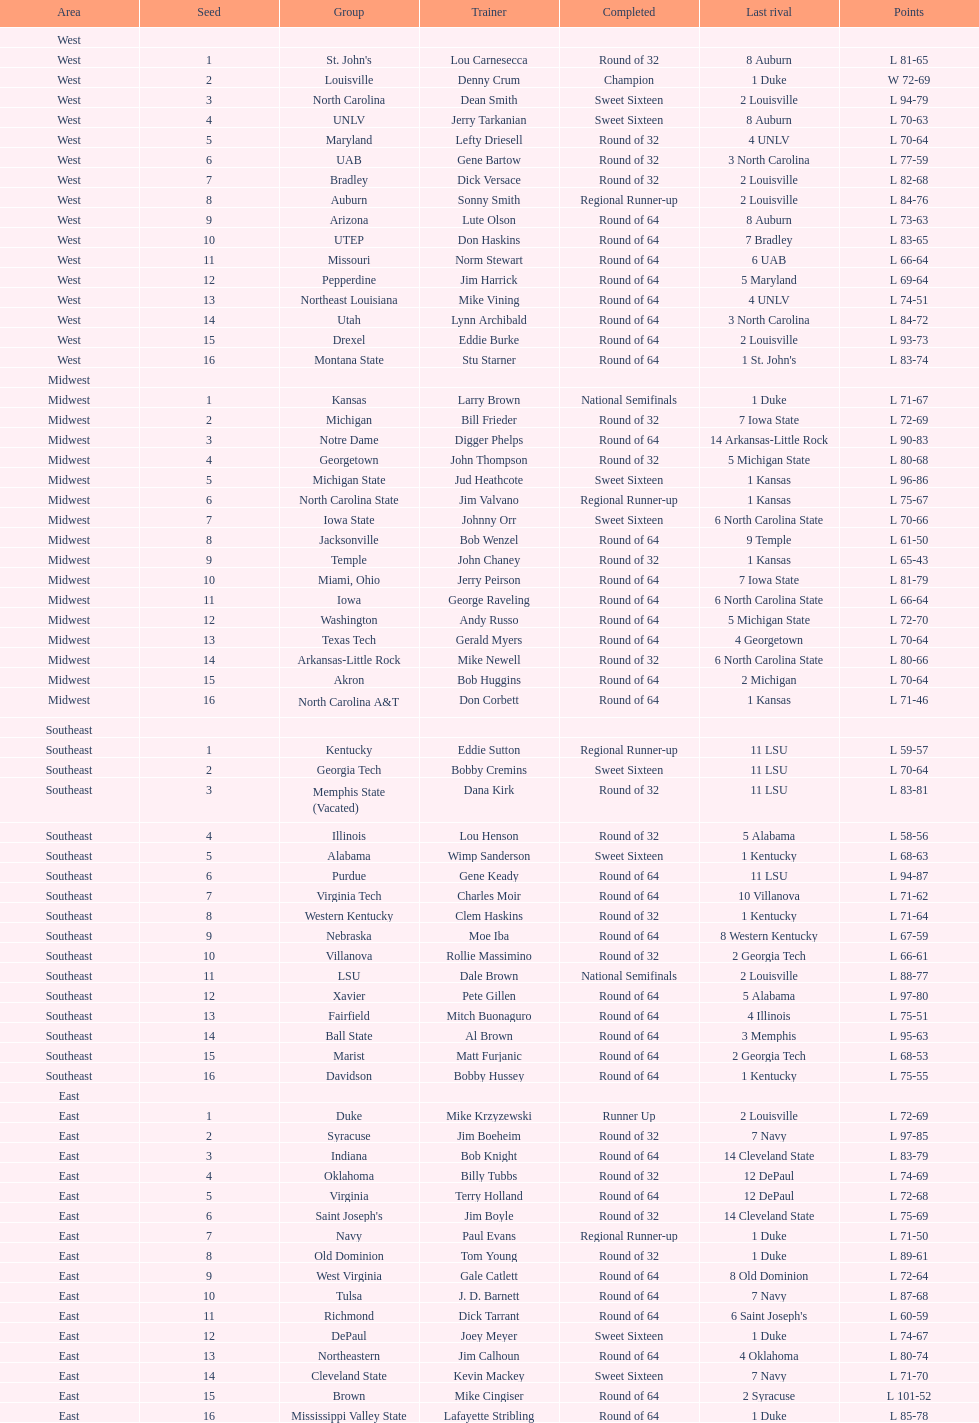Which area is mentioned prior to the midwest? West. Would you be able to parse every entry in this table? {'header': ['Area', 'Seed', 'Group', 'Trainer', 'Completed', 'Last rival', 'Points'], 'rows': [['West', '', '', '', '', '', ''], ['West', '1', "St. John's", 'Lou Carnesecca', 'Round of 32', '8 Auburn', 'L 81-65'], ['West', '2', 'Louisville', 'Denny Crum', 'Champion', '1 Duke', 'W 72-69'], ['West', '3', 'North Carolina', 'Dean Smith', 'Sweet Sixteen', '2 Louisville', 'L 94-79'], ['West', '4', 'UNLV', 'Jerry Tarkanian', 'Sweet Sixteen', '8 Auburn', 'L 70-63'], ['West', '5', 'Maryland', 'Lefty Driesell', 'Round of 32', '4 UNLV', 'L 70-64'], ['West', '6', 'UAB', 'Gene Bartow', 'Round of 32', '3 North Carolina', 'L 77-59'], ['West', '7', 'Bradley', 'Dick Versace', 'Round of 32', '2 Louisville', 'L 82-68'], ['West', '8', 'Auburn', 'Sonny Smith', 'Regional Runner-up', '2 Louisville', 'L 84-76'], ['West', '9', 'Arizona', 'Lute Olson', 'Round of 64', '8 Auburn', 'L 73-63'], ['West', '10', 'UTEP', 'Don Haskins', 'Round of 64', '7 Bradley', 'L 83-65'], ['West', '11', 'Missouri', 'Norm Stewart', 'Round of 64', '6 UAB', 'L 66-64'], ['West', '12', 'Pepperdine', 'Jim Harrick', 'Round of 64', '5 Maryland', 'L 69-64'], ['West', '13', 'Northeast Louisiana', 'Mike Vining', 'Round of 64', '4 UNLV', 'L 74-51'], ['West', '14', 'Utah', 'Lynn Archibald', 'Round of 64', '3 North Carolina', 'L 84-72'], ['West', '15', 'Drexel', 'Eddie Burke', 'Round of 64', '2 Louisville', 'L 93-73'], ['West', '16', 'Montana State', 'Stu Starner', 'Round of 64', "1 St. John's", 'L 83-74'], ['Midwest', '', '', '', '', '', ''], ['Midwest', '1', 'Kansas', 'Larry Brown', 'National Semifinals', '1 Duke', 'L 71-67'], ['Midwest', '2', 'Michigan', 'Bill Frieder', 'Round of 32', '7 Iowa State', 'L 72-69'], ['Midwest', '3', 'Notre Dame', 'Digger Phelps', 'Round of 64', '14 Arkansas-Little Rock', 'L 90-83'], ['Midwest', '4', 'Georgetown', 'John Thompson', 'Round of 32', '5 Michigan State', 'L 80-68'], ['Midwest', '5', 'Michigan State', 'Jud Heathcote', 'Sweet Sixteen', '1 Kansas', 'L 96-86'], ['Midwest', '6', 'North Carolina State', 'Jim Valvano', 'Regional Runner-up', '1 Kansas', 'L 75-67'], ['Midwest', '7', 'Iowa State', 'Johnny Orr', 'Sweet Sixteen', '6 North Carolina State', 'L 70-66'], ['Midwest', '8', 'Jacksonville', 'Bob Wenzel', 'Round of 64', '9 Temple', 'L 61-50'], ['Midwest', '9', 'Temple', 'John Chaney', 'Round of 32', '1 Kansas', 'L 65-43'], ['Midwest', '10', 'Miami, Ohio', 'Jerry Peirson', 'Round of 64', '7 Iowa State', 'L 81-79'], ['Midwest', '11', 'Iowa', 'George Raveling', 'Round of 64', '6 North Carolina State', 'L 66-64'], ['Midwest', '12', 'Washington', 'Andy Russo', 'Round of 64', '5 Michigan State', 'L 72-70'], ['Midwest', '13', 'Texas Tech', 'Gerald Myers', 'Round of 64', '4 Georgetown', 'L 70-64'], ['Midwest', '14', 'Arkansas-Little Rock', 'Mike Newell', 'Round of 32', '6 North Carolina State', 'L 80-66'], ['Midwest', '15', 'Akron', 'Bob Huggins', 'Round of 64', '2 Michigan', 'L 70-64'], ['Midwest', '16', 'North Carolina A&T', 'Don Corbett', 'Round of 64', '1 Kansas', 'L 71-46'], ['Southeast', '', '', '', '', '', ''], ['Southeast', '1', 'Kentucky', 'Eddie Sutton', 'Regional Runner-up', '11 LSU', 'L 59-57'], ['Southeast', '2', 'Georgia Tech', 'Bobby Cremins', 'Sweet Sixteen', '11 LSU', 'L 70-64'], ['Southeast', '3', 'Memphis State (Vacated)', 'Dana Kirk', 'Round of 32', '11 LSU', 'L 83-81'], ['Southeast', '4', 'Illinois', 'Lou Henson', 'Round of 32', '5 Alabama', 'L 58-56'], ['Southeast', '5', 'Alabama', 'Wimp Sanderson', 'Sweet Sixteen', '1 Kentucky', 'L 68-63'], ['Southeast', '6', 'Purdue', 'Gene Keady', 'Round of 64', '11 LSU', 'L 94-87'], ['Southeast', '7', 'Virginia Tech', 'Charles Moir', 'Round of 64', '10 Villanova', 'L 71-62'], ['Southeast', '8', 'Western Kentucky', 'Clem Haskins', 'Round of 32', '1 Kentucky', 'L 71-64'], ['Southeast', '9', 'Nebraska', 'Moe Iba', 'Round of 64', '8 Western Kentucky', 'L 67-59'], ['Southeast', '10', 'Villanova', 'Rollie Massimino', 'Round of 32', '2 Georgia Tech', 'L 66-61'], ['Southeast', '11', 'LSU', 'Dale Brown', 'National Semifinals', '2 Louisville', 'L 88-77'], ['Southeast', '12', 'Xavier', 'Pete Gillen', 'Round of 64', '5 Alabama', 'L 97-80'], ['Southeast', '13', 'Fairfield', 'Mitch Buonaguro', 'Round of 64', '4 Illinois', 'L 75-51'], ['Southeast', '14', 'Ball State', 'Al Brown', 'Round of 64', '3 Memphis', 'L 95-63'], ['Southeast', '15', 'Marist', 'Matt Furjanic', 'Round of 64', '2 Georgia Tech', 'L 68-53'], ['Southeast', '16', 'Davidson', 'Bobby Hussey', 'Round of 64', '1 Kentucky', 'L 75-55'], ['East', '', '', '', '', '', ''], ['East', '1', 'Duke', 'Mike Krzyzewski', 'Runner Up', '2 Louisville', 'L 72-69'], ['East', '2', 'Syracuse', 'Jim Boeheim', 'Round of 32', '7 Navy', 'L 97-85'], ['East', '3', 'Indiana', 'Bob Knight', 'Round of 64', '14 Cleveland State', 'L 83-79'], ['East', '4', 'Oklahoma', 'Billy Tubbs', 'Round of 32', '12 DePaul', 'L 74-69'], ['East', '5', 'Virginia', 'Terry Holland', 'Round of 64', '12 DePaul', 'L 72-68'], ['East', '6', "Saint Joseph's", 'Jim Boyle', 'Round of 32', '14 Cleveland State', 'L 75-69'], ['East', '7', 'Navy', 'Paul Evans', 'Regional Runner-up', '1 Duke', 'L 71-50'], ['East', '8', 'Old Dominion', 'Tom Young', 'Round of 32', '1 Duke', 'L 89-61'], ['East', '9', 'West Virginia', 'Gale Catlett', 'Round of 64', '8 Old Dominion', 'L 72-64'], ['East', '10', 'Tulsa', 'J. D. Barnett', 'Round of 64', '7 Navy', 'L 87-68'], ['East', '11', 'Richmond', 'Dick Tarrant', 'Round of 64', "6 Saint Joseph's", 'L 60-59'], ['East', '12', 'DePaul', 'Joey Meyer', 'Sweet Sixteen', '1 Duke', 'L 74-67'], ['East', '13', 'Northeastern', 'Jim Calhoun', 'Round of 64', '4 Oklahoma', 'L 80-74'], ['East', '14', 'Cleveland State', 'Kevin Mackey', 'Sweet Sixteen', '7 Navy', 'L 71-70'], ['East', '15', 'Brown', 'Mike Cingiser', 'Round of 64', '2 Syracuse', 'L 101-52'], ['East', '16', 'Mississippi Valley State', 'Lafayette Stribling', 'Round of 64', '1 Duke', 'L 85-78']]} 